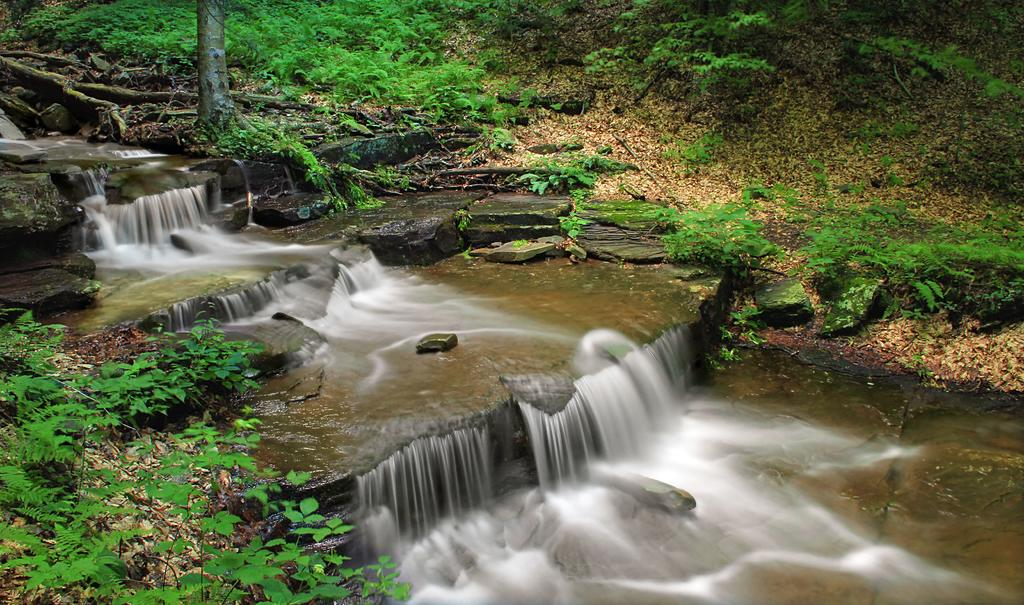What is the primary element flowing in the image? There is water flowing in the image. What type of natural features can be seen in the image? There are rocks, plants, and trees visible in the image. What type of yard can be seen in the image? There is no yard present in the image. What part of the human body can be seen in the image? There is no part of the human body, such as the brain, present in the image. 